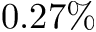Convert formula to latex. <formula><loc_0><loc_0><loc_500><loc_500>0 . 2 7 \%</formula> 